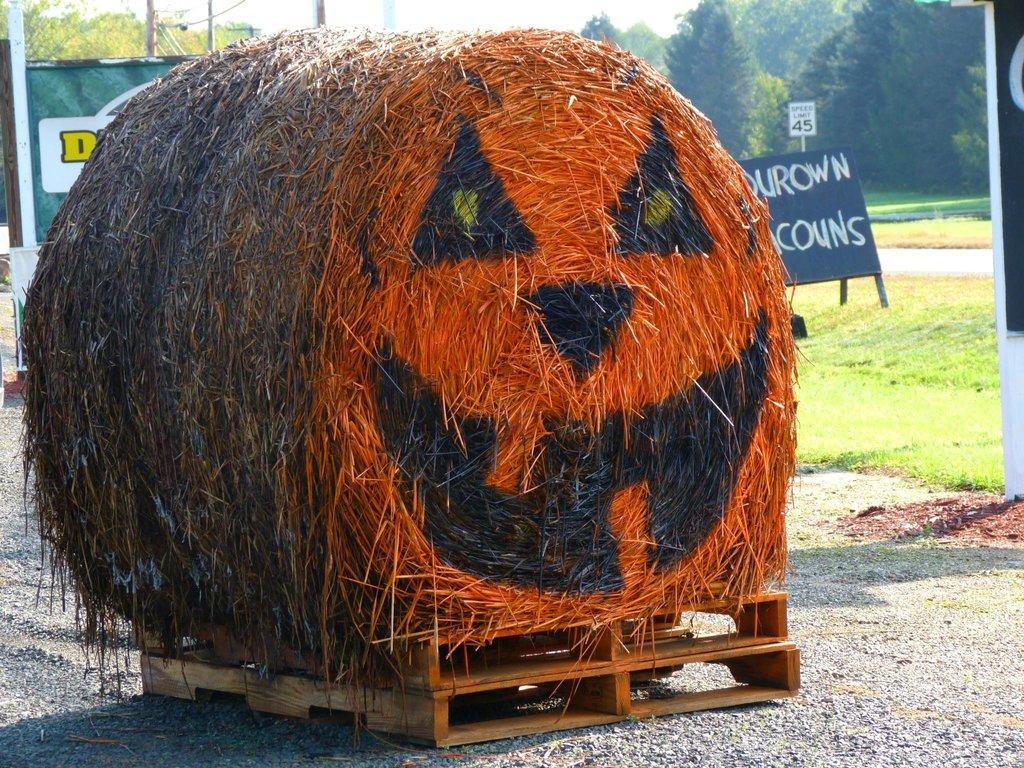How would you summarize this image in a sentence or two? In the foreground I can see grass roll on a wooden box. In the background I can see grass, boards, posters, trees and the sky. This image is taken, may be during a day. 